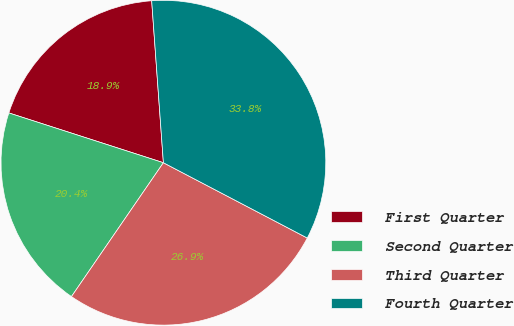<chart> <loc_0><loc_0><loc_500><loc_500><pie_chart><fcel>First Quarter<fcel>Second Quarter<fcel>Third Quarter<fcel>Fourth Quarter<nl><fcel>18.89%<fcel>20.38%<fcel>26.9%<fcel>33.82%<nl></chart> 